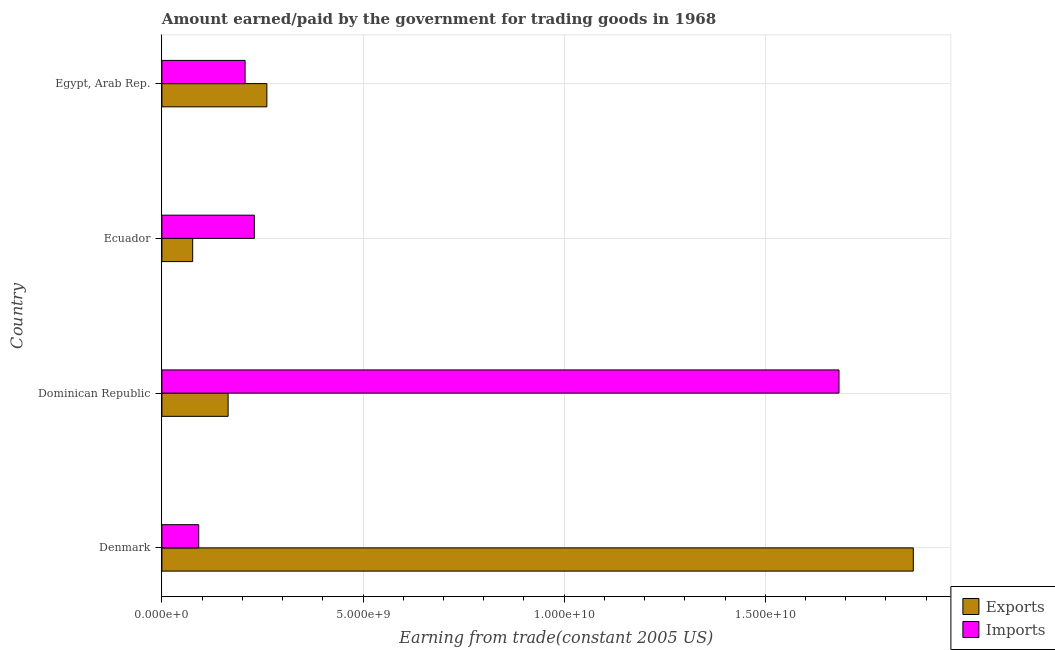How many groups of bars are there?
Ensure brevity in your answer.  4. Are the number of bars per tick equal to the number of legend labels?
Your response must be concise. Yes. Are the number of bars on each tick of the Y-axis equal?
Give a very brief answer. Yes. How many bars are there on the 2nd tick from the top?
Provide a short and direct response. 2. What is the label of the 1st group of bars from the top?
Make the answer very short. Egypt, Arab Rep. What is the amount earned from exports in Egypt, Arab Rep.?
Make the answer very short. 2.61e+09. Across all countries, what is the maximum amount paid for imports?
Ensure brevity in your answer.  1.68e+1. Across all countries, what is the minimum amount paid for imports?
Make the answer very short. 9.15e+08. In which country was the amount paid for imports maximum?
Ensure brevity in your answer.  Dominican Republic. In which country was the amount earned from exports minimum?
Keep it short and to the point. Ecuador. What is the total amount earned from exports in the graph?
Keep it short and to the point. 2.37e+1. What is the difference between the amount earned from exports in Ecuador and that in Egypt, Arab Rep.?
Offer a terse response. -1.84e+09. What is the difference between the amount paid for imports in Dominican Republic and the amount earned from exports in Egypt, Arab Rep.?
Provide a succinct answer. 1.42e+1. What is the average amount paid for imports per country?
Your answer should be very brief. 5.53e+09. What is the difference between the amount paid for imports and amount earned from exports in Denmark?
Provide a short and direct response. -1.78e+1. In how many countries, is the amount earned from exports greater than 4000000000 US$?
Offer a very short reply. 1. What is the ratio of the amount paid for imports in Ecuador to that in Egypt, Arab Rep.?
Your answer should be compact. 1.11. Is the amount paid for imports in Denmark less than that in Ecuador?
Your answer should be compact. Yes. What is the difference between the highest and the second highest amount paid for imports?
Offer a terse response. 1.45e+1. What is the difference between the highest and the lowest amount earned from exports?
Your answer should be very brief. 1.79e+1. Is the sum of the amount earned from exports in Ecuador and Egypt, Arab Rep. greater than the maximum amount paid for imports across all countries?
Your answer should be compact. No. What does the 1st bar from the top in Egypt, Arab Rep. represents?
Offer a very short reply. Imports. What does the 1st bar from the bottom in Denmark represents?
Your response must be concise. Exports. How many bars are there?
Your answer should be compact. 8. How many countries are there in the graph?
Provide a succinct answer. 4. What is the difference between two consecutive major ticks on the X-axis?
Keep it short and to the point. 5.00e+09. How many legend labels are there?
Keep it short and to the point. 2. What is the title of the graph?
Make the answer very short. Amount earned/paid by the government for trading goods in 1968. Does "Malaria" appear as one of the legend labels in the graph?
Make the answer very short. No. What is the label or title of the X-axis?
Keep it short and to the point. Earning from trade(constant 2005 US). What is the Earning from trade(constant 2005 US) of Exports in Denmark?
Your answer should be very brief. 1.87e+1. What is the Earning from trade(constant 2005 US) in Imports in Denmark?
Ensure brevity in your answer.  9.15e+08. What is the Earning from trade(constant 2005 US) in Exports in Dominican Republic?
Make the answer very short. 1.65e+09. What is the Earning from trade(constant 2005 US) of Imports in Dominican Republic?
Your response must be concise. 1.68e+1. What is the Earning from trade(constant 2005 US) of Exports in Ecuador?
Your answer should be very brief. 7.65e+08. What is the Earning from trade(constant 2005 US) of Imports in Ecuador?
Ensure brevity in your answer.  2.30e+09. What is the Earning from trade(constant 2005 US) of Exports in Egypt, Arab Rep.?
Ensure brevity in your answer.  2.61e+09. What is the Earning from trade(constant 2005 US) of Imports in Egypt, Arab Rep.?
Keep it short and to the point. 2.07e+09. Across all countries, what is the maximum Earning from trade(constant 2005 US) in Exports?
Offer a very short reply. 1.87e+1. Across all countries, what is the maximum Earning from trade(constant 2005 US) in Imports?
Your response must be concise. 1.68e+1. Across all countries, what is the minimum Earning from trade(constant 2005 US) of Exports?
Give a very brief answer. 7.65e+08. Across all countries, what is the minimum Earning from trade(constant 2005 US) of Imports?
Ensure brevity in your answer.  9.15e+08. What is the total Earning from trade(constant 2005 US) of Exports in the graph?
Your response must be concise. 2.37e+1. What is the total Earning from trade(constant 2005 US) in Imports in the graph?
Provide a short and direct response. 2.21e+1. What is the difference between the Earning from trade(constant 2005 US) of Exports in Denmark and that in Dominican Republic?
Give a very brief answer. 1.70e+1. What is the difference between the Earning from trade(constant 2005 US) of Imports in Denmark and that in Dominican Republic?
Your response must be concise. -1.59e+1. What is the difference between the Earning from trade(constant 2005 US) in Exports in Denmark and that in Ecuador?
Your answer should be compact. 1.79e+1. What is the difference between the Earning from trade(constant 2005 US) of Imports in Denmark and that in Ecuador?
Ensure brevity in your answer.  -1.38e+09. What is the difference between the Earning from trade(constant 2005 US) of Exports in Denmark and that in Egypt, Arab Rep.?
Your answer should be very brief. 1.61e+1. What is the difference between the Earning from trade(constant 2005 US) of Imports in Denmark and that in Egypt, Arab Rep.?
Offer a very short reply. -1.15e+09. What is the difference between the Earning from trade(constant 2005 US) in Exports in Dominican Republic and that in Ecuador?
Your response must be concise. 8.81e+08. What is the difference between the Earning from trade(constant 2005 US) in Imports in Dominican Republic and that in Ecuador?
Provide a short and direct response. 1.45e+1. What is the difference between the Earning from trade(constant 2005 US) of Exports in Dominican Republic and that in Egypt, Arab Rep.?
Offer a terse response. -9.64e+08. What is the difference between the Earning from trade(constant 2005 US) of Imports in Dominican Republic and that in Egypt, Arab Rep.?
Make the answer very short. 1.48e+1. What is the difference between the Earning from trade(constant 2005 US) of Exports in Ecuador and that in Egypt, Arab Rep.?
Give a very brief answer. -1.84e+09. What is the difference between the Earning from trade(constant 2005 US) in Imports in Ecuador and that in Egypt, Arab Rep.?
Provide a short and direct response. 2.30e+08. What is the difference between the Earning from trade(constant 2005 US) of Exports in Denmark and the Earning from trade(constant 2005 US) of Imports in Dominican Republic?
Give a very brief answer. 1.85e+09. What is the difference between the Earning from trade(constant 2005 US) of Exports in Denmark and the Earning from trade(constant 2005 US) of Imports in Ecuador?
Your answer should be compact. 1.64e+1. What is the difference between the Earning from trade(constant 2005 US) in Exports in Denmark and the Earning from trade(constant 2005 US) in Imports in Egypt, Arab Rep.?
Offer a very short reply. 1.66e+1. What is the difference between the Earning from trade(constant 2005 US) in Exports in Dominican Republic and the Earning from trade(constant 2005 US) in Imports in Ecuador?
Give a very brief answer. -6.52e+08. What is the difference between the Earning from trade(constant 2005 US) of Exports in Dominican Republic and the Earning from trade(constant 2005 US) of Imports in Egypt, Arab Rep.?
Your response must be concise. -4.22e+08. What is the difference between the Earning from trade(constant 2005 US) in Exports in Ecuador and the Earning from trade(constant 2005 US) in Imports in Egypt, Arab Rep.?
Your answer should be compact. -1.30e+09. What is the average Earning from trade(constant 2005 US) in Exports per country?
Ensure brevity in your answer.  5.93e+09. What is the average Earning from trade(constant 2005 US) of Imports per country?
Provide a short and direct response. 5.53e+09. What is the difference between the Earning from trade(constant 2005 US) in Exports and Earning from trade(constant 2005 US) in Imports in Denmark?
Your answer should be very brief. 1.78e+1. What is the difference between the Earning from trade(constant 2005 US) in Exports and Earning from trade(constant 2005 US) in Imports in Dominican Republic?
Your response must be concise. -1.52e+1. What is the difference between the Earning from trade(constant 2005 US) of Exports and Earning from trade(constant 2005 US) of Imports in Ecuador?
Provide a succinct answer. -1.53e+09. What is the difference between the Earning from trade(constant 2005 US) of Exports and Earning from trade(constant 2005 US) of Imports in Egypt, Arab Rep.?
Offer a terse response. 5.41e+08. What is the ratio of the Earning from trade(constant 2005 US) of Exports in Denmark to that in Dominican Republic?
Offer a very short reply. 11.35. What is the ratio of the Earning from trade(constant 2005 US) of Imports in Denmark to that in Dominican Republic?
Provide a short and direct response. 0.05. What is the ratio of the Earning from trade(constant 2005 US) of Exports in Denmark to that in Ecuador?
Offer a very short reply. 24.41. What is the ratio of the Earning from trade(constant 2005 US) of Imports in Denmark to that in Ecuador?
Keep it short and to the point. 0.4. What is the ratio of the Earning from trade(constant 2005 US) in Exports in Denmark to that in Egypt, Arab Rep.?
Ensure brevity in your answer.  7.16. What is the ratio of the Earning from trade(constant 2005 US) in Imports in Denmark to that in Egypt, Arab Rep.?
Provide a succinct answer. 0.44. What is the ratio of the Earning from trade(constant 2005 US) in Exports in Dominican Republic to that in Ecuador?
Ensure brevity in your answer.  2.15. What is the ratio of the Earning from trade(constant 2005 US) of Imports in Dominican Republic to that in Ecuador?
Ensure brevity in your answer.  7.32. What is the ratio of the Earning from trade(constant 2005 US) in Exports in Dominican Republic to that in Egypt, Arab Rep.?
Keep it short and to the point. 0.63. What is the ratio of the Earning from trade(constant 2005 US) of Imports in Dominican Republic to that in Egypt, Arab Rep.?
Offer a terse response. 8.14. What is the ratio of the Earning from trade(constant 2005 US) in Exports in Ecuador to that in Egypt, Arab Rep.?
Offer a terse response. 0.29. What is the ratio of the Earning from trade(constant 2005 US) of Imports in Ecuador to that in Egypt, Arab Rep.?
Keep it short and to the point. 1.11. What is the difference between the highest and the second highest Earning from trade(constant 2005 US) of Exports?
Your response must be concise. 1.61e+1. What is the difference between the highest and the second highest Earning from trade(constant 2005 US) in Imports?
Your answer should be very brief. 1.45e+1. What is the difference between the highest and the lowest Earning from trade(constant 2005 US) of Exports?
Keep it short and to the point. 1.79e+1. What is the difference between the highest and the lowest Earning from trade(constant 2005 US) of Imports?
Provide a succinct answer. 1.59e+1. 